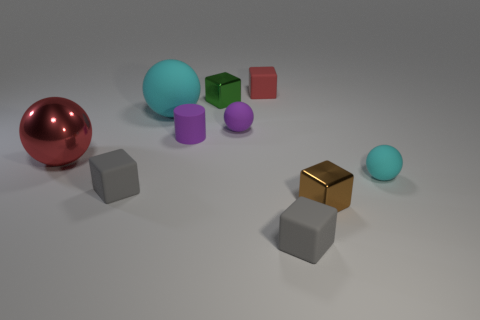How many tiny objects are green cubes or gray things?
Provide a short and direct response. 3. Does the brown thing have the same shape as the tiny cyan rubber thing?
Provide a succinct answer. No. How many tiny rubber things are both in front of the big cyan matte sphere and behind the big rubber sphere?
Keep it short and to the point. 0. Are there any other things that are the same color as the tiny matte cylinder?
Give a very brief answer. Yes. What shape is the red object that is made of the same material as the brown block?
Offer a very short reply. Sphere. Do the red block and the green metal object have the same size?
Your answer should be very brief. Yes. Does the gray thing on the right side of the rubber cylinder have the same material as the small brown object?
Your response must be concise. No. Are there any other things that are the same material as the small green cube?
Provide a succinct answer. Yes. There is a cyan ball right of the brown cube that is in front of the red matte thing; what number of tiny green metal things are in front of it?
Make the answer very short. 0. Is the shape of the red thing in front of the small matte cylinder the same as  the green metallic thing?
Your response must be concise. No. 